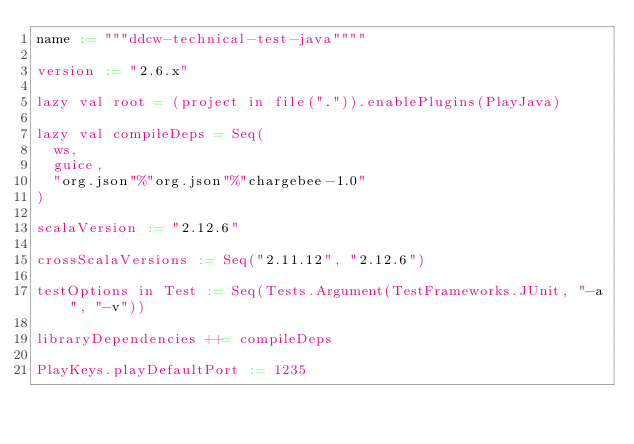<code> <loc_0><loc_0><loc_500><loc_500><_Scala_>name := """ddcw-technical-test-java""""

version := "2.6.x"

lazy val root = (project in file(".")).enablePlugins(PlayJava)

lazy val compileDeps = Seq(
  ws,
  guice,
  "org.json"%"org.json"%"chargebee-1.0"
)

scalaVersion := "2.12.6"

crossScalaVersions := Seq("2.11.12", "2.12.6")

testOptions in Test := Seq(Tests.Argument(TestFrameworks.JUnit, "-a", "-v"))

libraryDependencies ++= compileDeps

PlayKeys.playDefaultPort := 1235</code> 